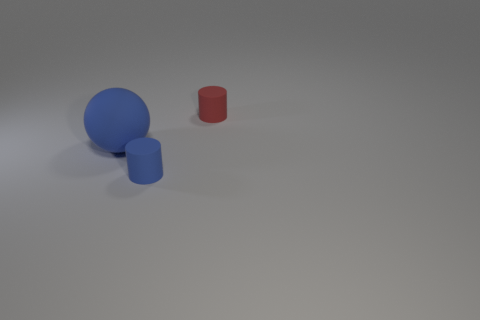Add 2 tiny cyan balls. How many objects exist? 5 Subtract all cylinders. How many objects are left? 1 Add 3 big blue objects. How many big blue objects exist? 4 Subtract 0 red cubes. How many objects are left? 3 Subtract all tiny cyan cylinders. Subtract all big things. How many objects are left? 2 Add 1 tiny red matte cylinders. How many tiny red matte cylinders are left? 2 